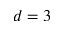<formula> <loc_0><loc_0><loc_500><loc_500>d = 3</formula> 